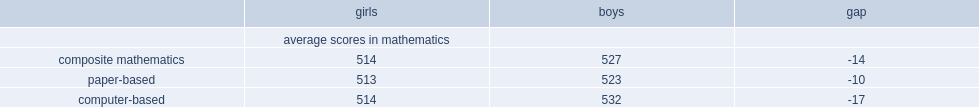What were the average scores for girls in computer-based math and paper-based math respectively? 514.0 513.0. Which composite mathematics had a larger gap between boys and girls? Computer-based. 